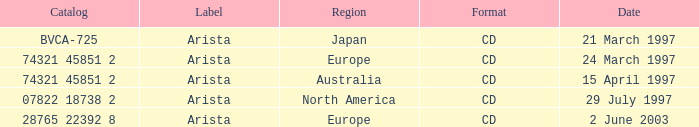What's the Date for the Region of Europe and has the Catalog of 28765 22392 8? 2 June 2003. 